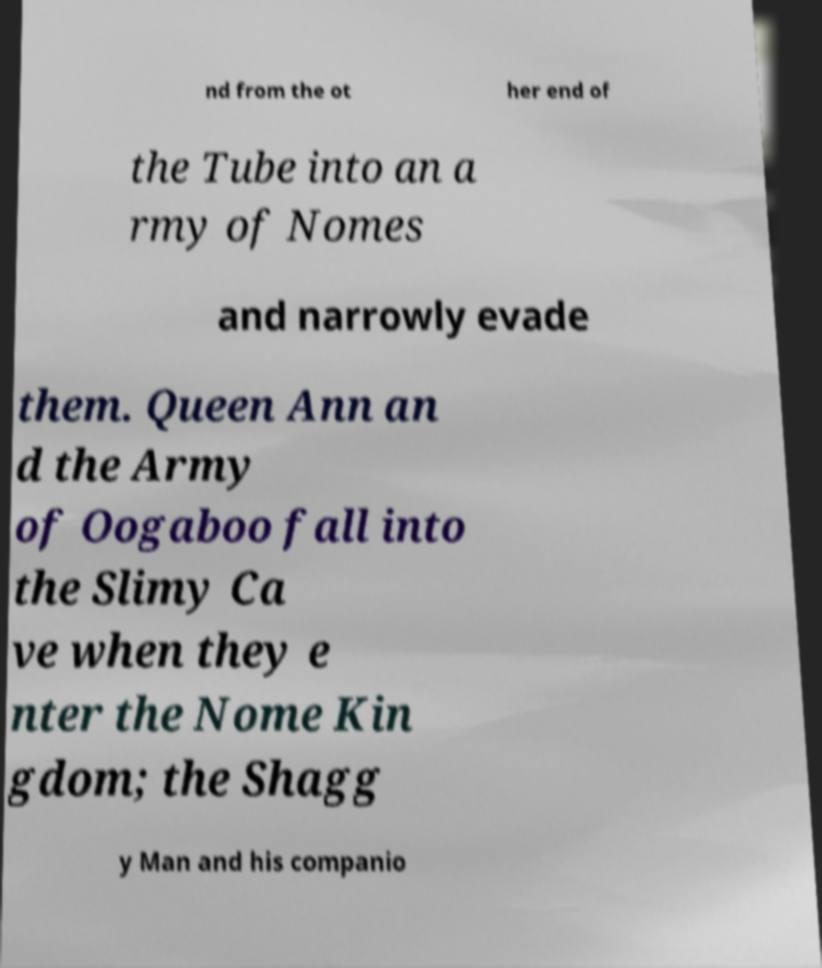I need the written content from this picture converted into text. Can you do that? nd from the ot her end of the Tube into an a rmy of Nomes and narrowly evade them. Queen Ann an d the Army of Oogaboo fall into the Slimy Ca ve when they e nter the Nome Kin gdom; the Shagg y Man and his companio 